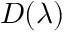Convert formula to latex. <formula><loc_0><loc_0><loc_500><loc_500>D ( \lambda )</formula> 